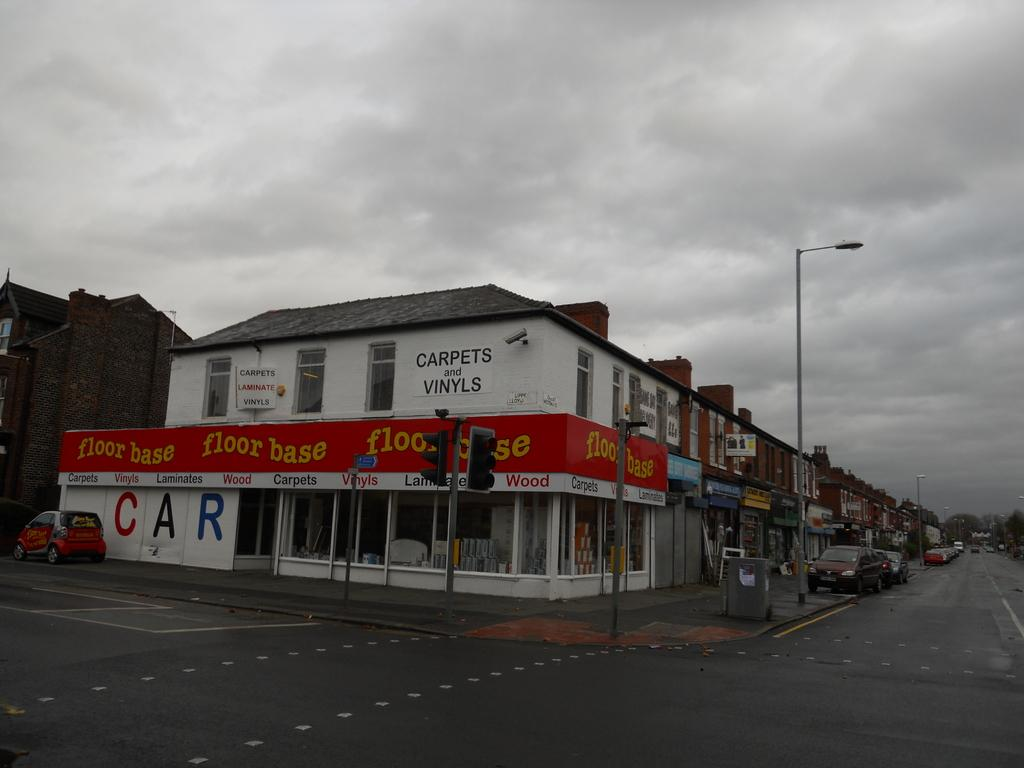What is the main feature of the image? There is a road in the image. What types of vehicles can be seen on the road? There are cars in the image. What helps regulate the flow of traffic in the image? There are traffic signals in the image. What structures can be seen alongside the road? There are poles and buildings in the image. What type of vegetation is visible in the background of the image? There are trees in the image, located at the back. How does the base of the trees help support the crowd in the image? There is no crowd present in the image, and the trees' bases do not support any crowd. 